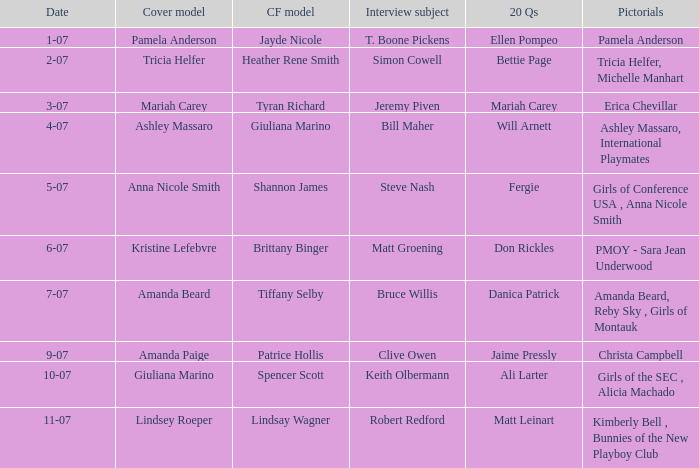List the pictorals from issues when lindsey roeper was the cover model. Kimberly Bell , Bunnies of the New Playboy Club. 